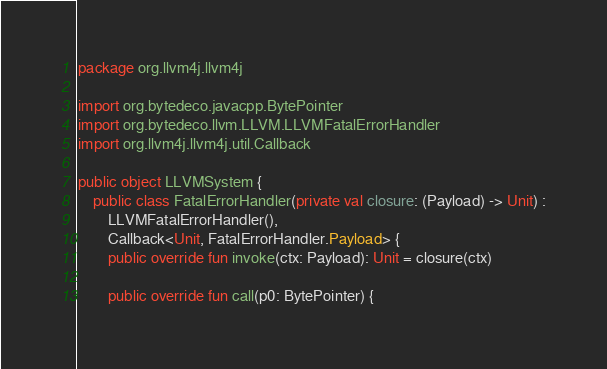Convert code to text. <code><loc_0><loc_0><loc_500><loc_500><_Kotlin_>package org.llvm4j.llvm4j

import org.bytedeco.javacpp.BytePointer
import org.bytedeco.llvm.LLVM.LLVMFatalErrorHandler
import org.llvm4j.llvm4j.util.Callback

public object LLVMSystem {
    public class FatalErrorHandler(private val closure: (Payload) -> Unit) :
        LLVMFatalErrorHandler(),
        Callback<Unit, FatalErrorHandler.Payload> {
        public override fun invoke(ctx: Payload): Unit = closure(ctx)

        public override fun call(p0: BytePointer) {</code> 